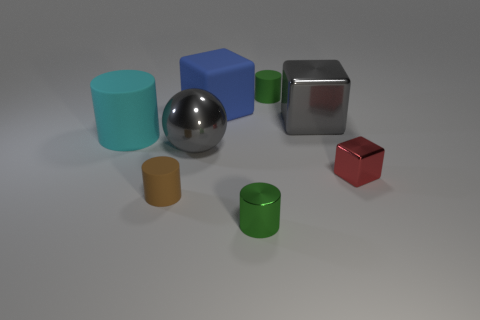What size is the green matte thing that is the same shape as the large cyan object?
Your answer should be very brief. Small. How many metallic blocks have the same color as the big metallic sphere?
Keep it short and to the point. 1. There is a matte cylinder that is on the right side of the big metal ball; does it have the same size as the gray object that is behind the large matte cylinder?
Your response must be concise. No. Are there the same number of large rubber blocks in front of the cyan matte cylinder and green matte cylinders that are left of the tiny brown cylinder?
Keep it short and to the point. Yes. Does the matte thing in front of the red shiny cube have the same shape as the big blue thing?
Keep it short and to the point. No. Is the shape of the cyan matte thing the same as the large blue object?
Offer a terse response. No. How many shiny things are yellow blocks or green cylinders?
Your response must be concise. 1. There is a block that is the same color as the metal ball; what material is it?
Make the answer very short. Metal. Do the red thing and the cyan cylinder have the same size?
Offer a terse response. No. What number of objects are tiny red metallic objects or matte objects that are in front of the blue matte thing?
Ensure brevity in your answer.  3. 